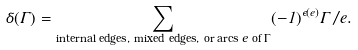<formula> <loc_0><loc_0><loc_500><loc_500>\delta ( \Gamma ) = \sum _ { \text {internal edges, mixed edges, or arcs $e$ of $\Gamma$} } ( - 1 ) ^ { \epsilon ( e ) } \Gamma / e .</formula> 